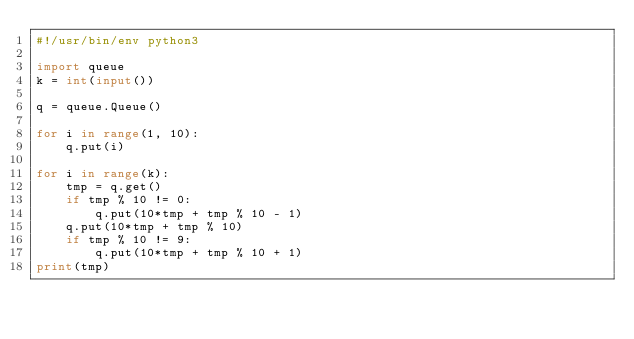<code> <loc_0><loc_0><loc_500><loc_500><_Python_>#!/usr/bin/env python3

import queue
k = int(input())

q = queue.Queue()

for i in range(1, 10):
    q.put(i)

for i in range(k):
    tmp = q.get()
    if tmp % 10 != 0:
        q.put(10*tmp + tmp % 10 - 1)
    q.put(10*tmp + tmp % 10)
    if tmp % 10 != 9:
        q.put(10*tmp + tmp % 10 + 1)
print(tmp)
</code> 